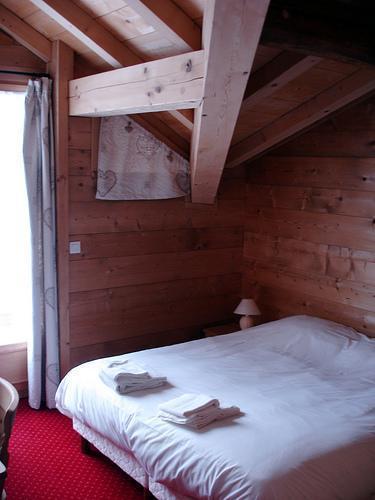How many beds are there?
Give a very brief answer. 1. 